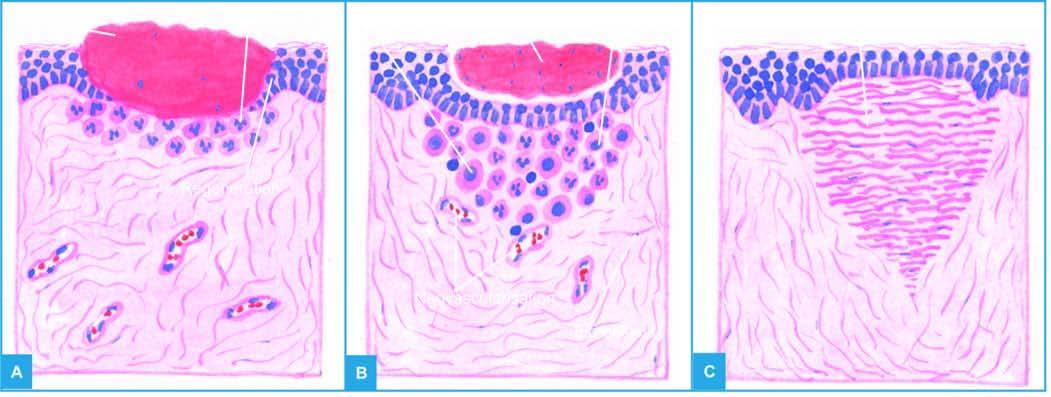do the dead cell seen in singles meet in the middle to cover the gap and separate the underlying viable tissue from necrotic tissue at the surface forming scab?
Answer the question using a single word or phrase. No 